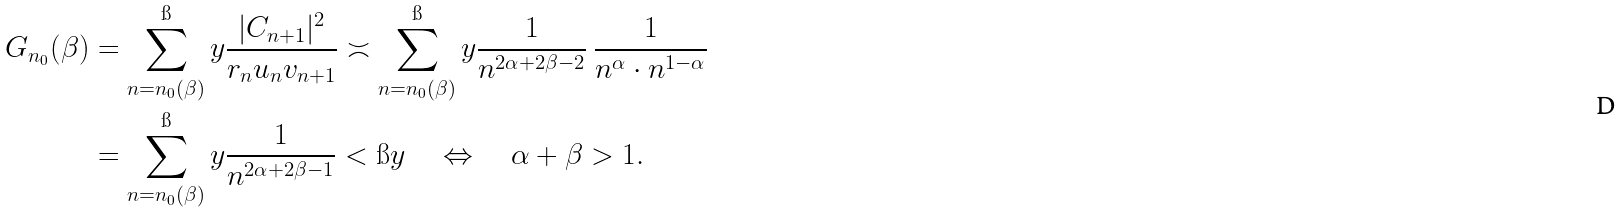Convert formula to latex. <formula><loc_0><loc_0><loc_500><loc_500>G _ { n _ { 0 } } ( \beta ) & = \sum _ { n = n _ { 0 } ( \beta ) } ^ { \i } y \frac { | C _ { n + 1 } | ^ { 2 } } { r _ { n } u _ { n } v _ { n + 1 } } \asymp \sum _ { n = n _ { 0 } ( \beta ) } ^ { \i } y \frac { 1 } { n ^ { 2 \alpha + 2 \beta - 2 } } \ \frac { 1 } { n ^ { \alpha } \cdot n ^ { 1 - \alpha } } \\ & = \sum _ { n = n _ { 0 } ( \beta ) } ^ { \i } y \frac { 1 } { n ^ { 2 \alpha + 2 \beta - 1 } } < \i y \quad \Leftrightarrow \quad \alpha + \beta > 1 .</formula> 